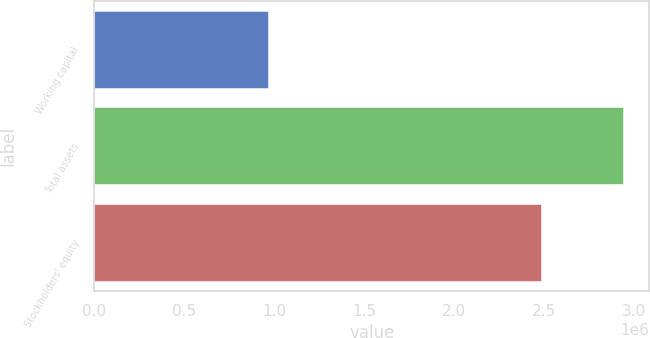<chart> <loc_0><loc_0><loc_500><loc_500><bar_chart><fcel>Working capital<fcel>Total assets<fcel>Stockholders' equity<nl><fcel>965657<fcel>2.93747e+06<fcel>2.48306e+06<nl></chart> 